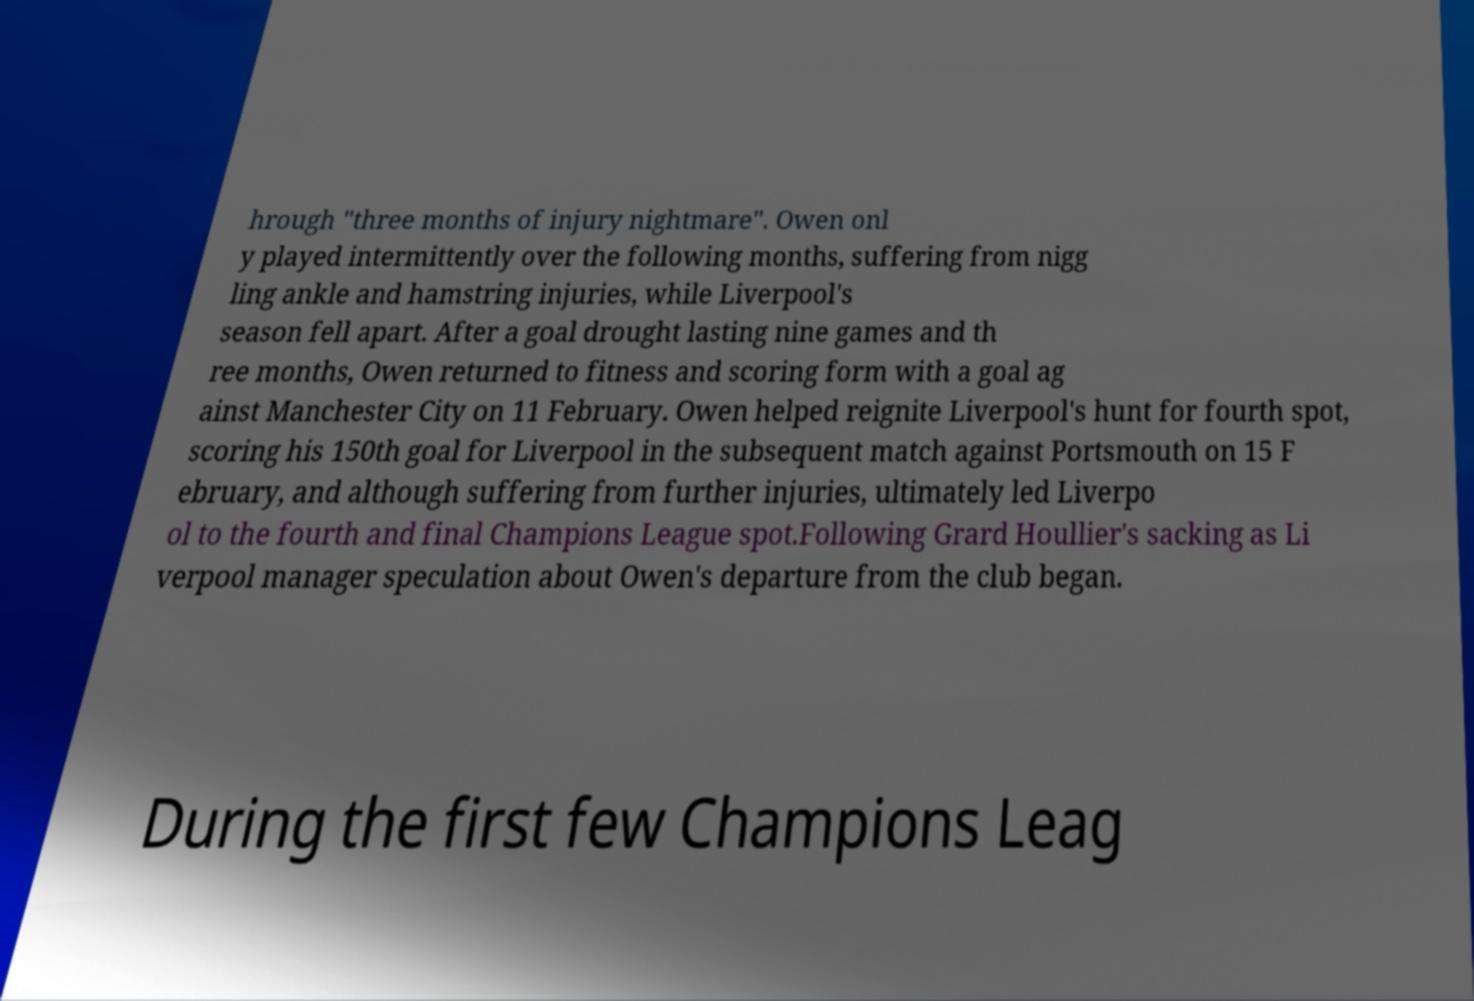Can you accurately transcribe the text from the provided image for me? hrough "three months of injury nightmare". Owen onl y played intermittently over the following months, suffering from nigg ling ankle and hamstring injuries, while Liverpool's season fell apart. After a goal drought lasting nine games and th ree months, Owen returned to fitness and scoring form with a goal ag ainst Manchester City on 11 February. Owen helped reignite Liverpool's hunt for fourth spot, scoring his 150th goal for Liverpool in the subsequent match against Portsmouth on 15 F ebruary, and although suffering from further injuries, ultimately led Liverpo ol to the fourth and final Champions League spot.Following Grard Houllier's sacking as Li verpool manager speculation about Owen's departure from the club began. During the first few Champions Leag 